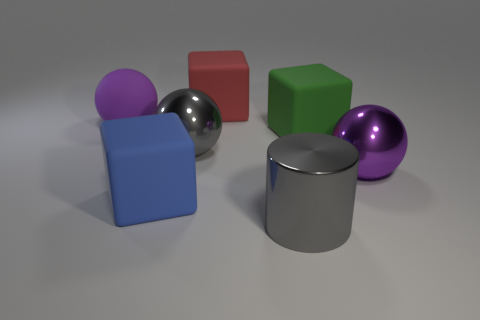Is the material of the gray object that is to the left of the red block the same as the big blue thing?
Offer a very short reply. No. What is the big red thing made of?
Give a very brief answer. Rubber. What size is the purple sphere that is in front of the big gray ball?
Provide a short and direct response. Large. Are there any other things that have the same color as the shiny cylinder?
Make the answer very short. Yes. There is a large gray metallic object on the left side of the big cylinder that is to the right of the large purple rubber thing; is there a big blue cube right of it?
Provide a short and direct response. No. There is a large metallic object that is to the right of the green matte object; does it have the same color as the rubber sphere?
Offer a terse response. Yes. What number of balls are either big green things or metallic objects?
Your response must be concise. 2. There is a gray shiny object behind the big shiny ball that is to the right of the large red matte thing; what is its shape?
Offer a very short reply. Sphere. There is a purple thing in front of the big purple object that is behind the large gray metallic thing that is on the left side of the big red rubber block; what is its size?
Make the answer very short. Large. Is the size of the cylinder the same as the red rubber cube?
Offer a very short reply. Yes. 